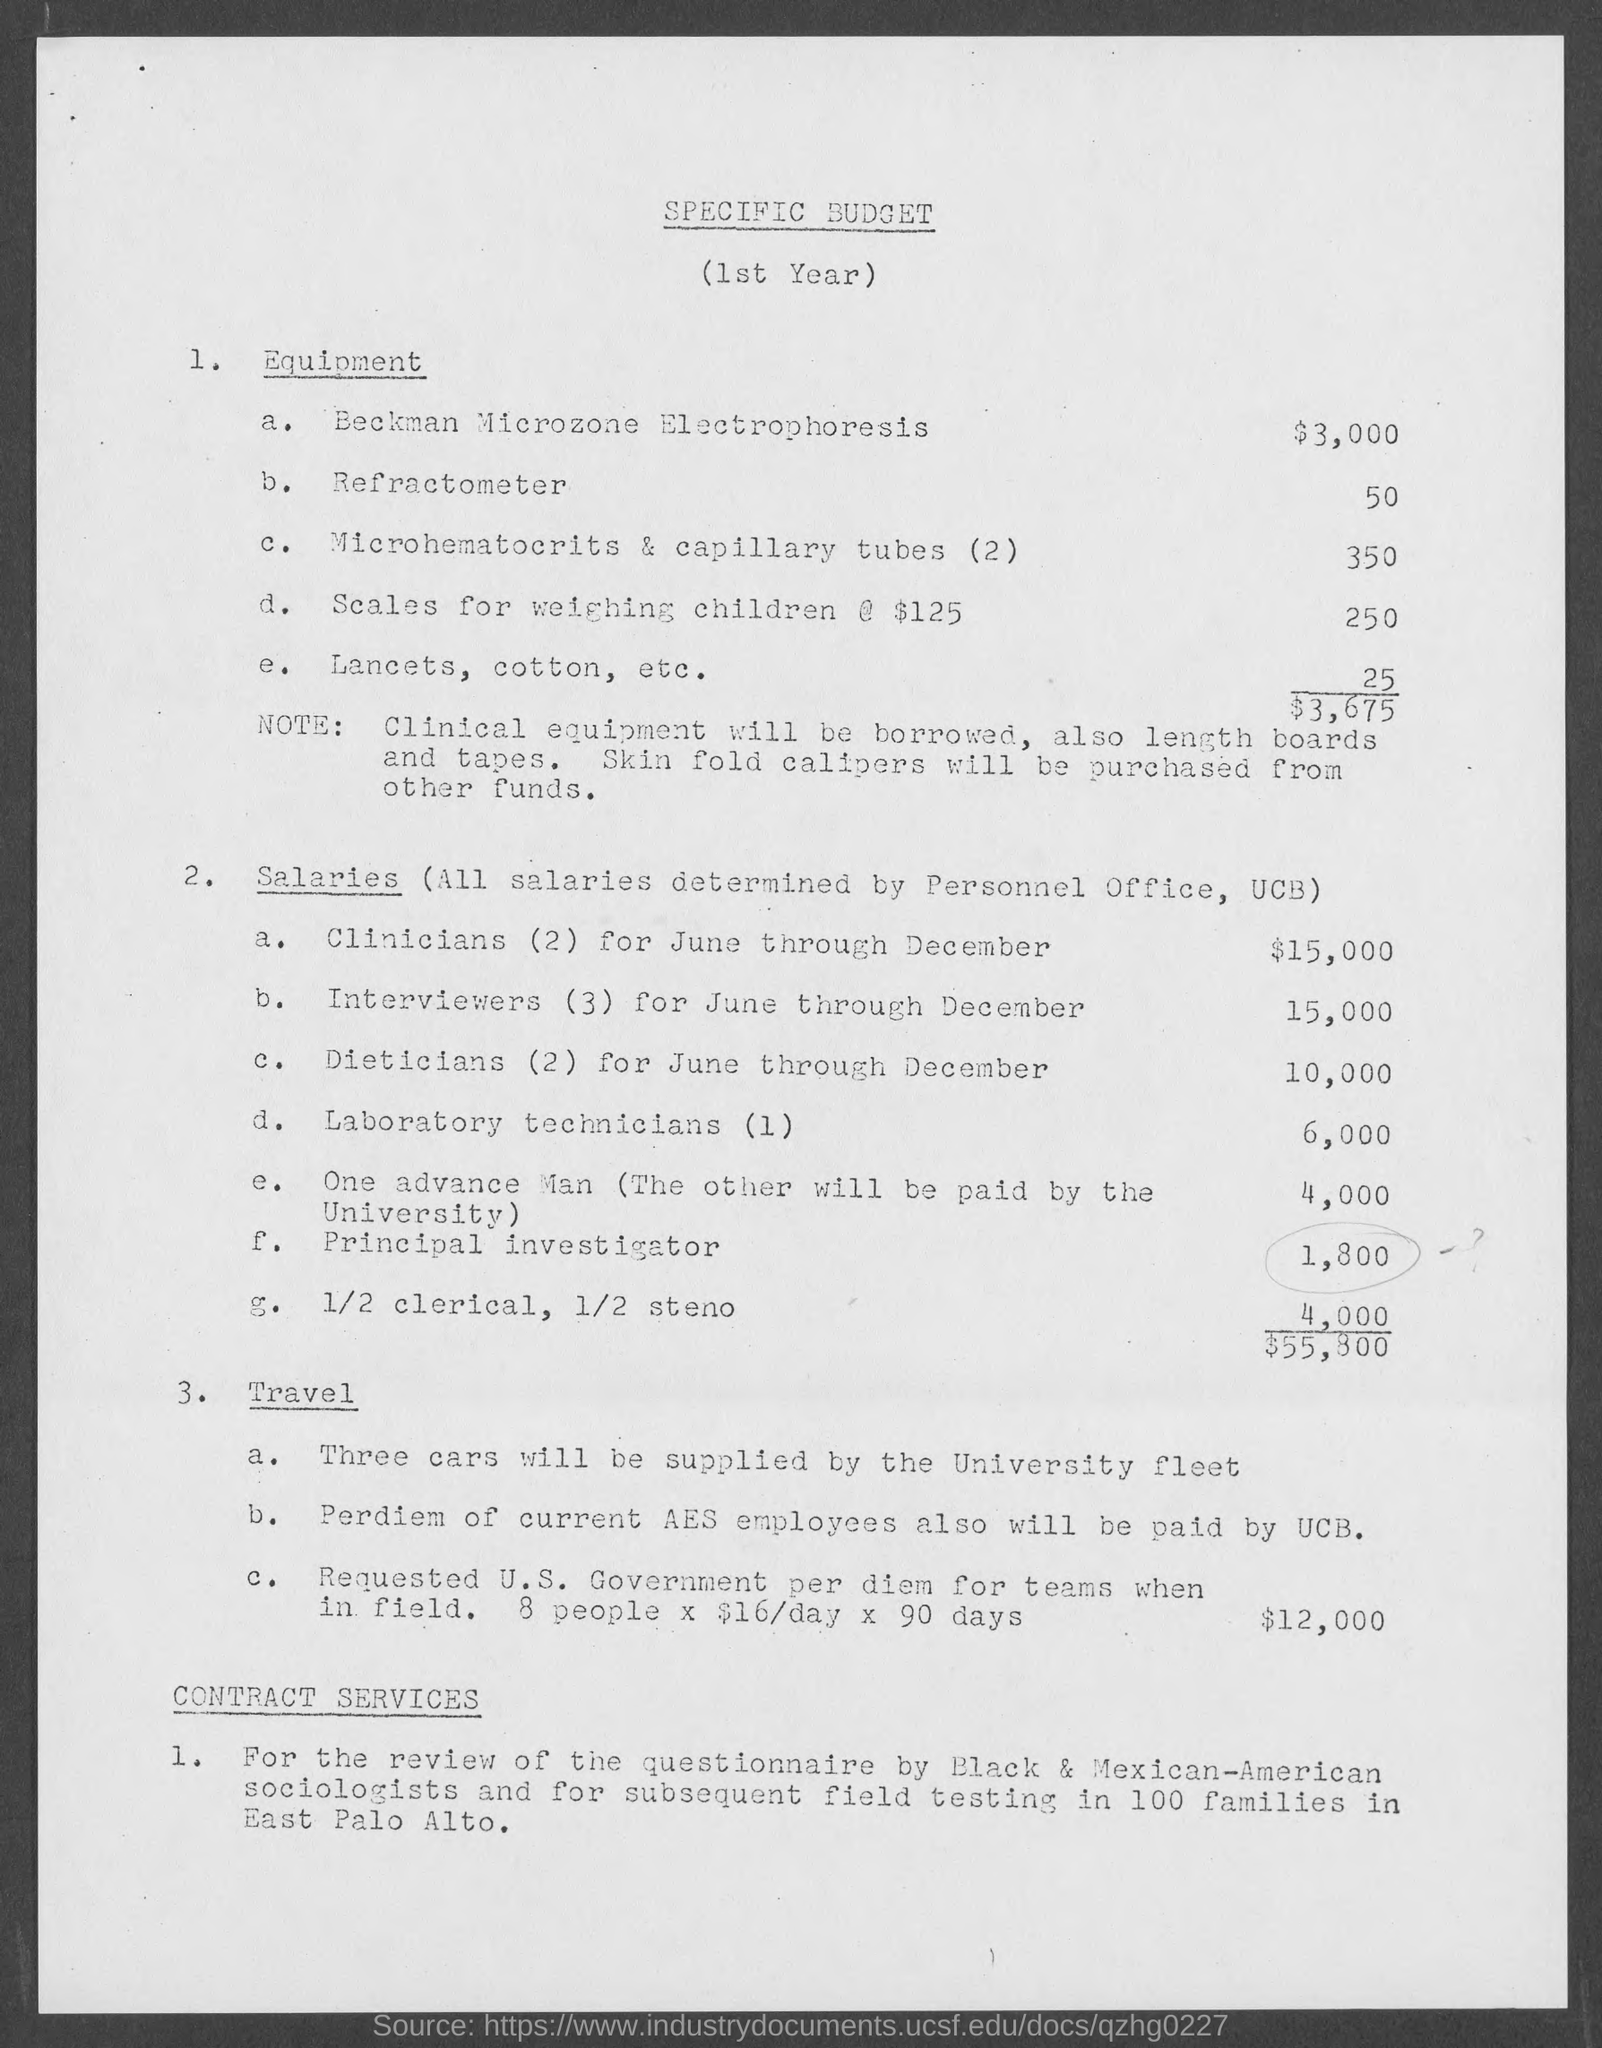What is the Cost for Beckman Microzone Electrophoresis?
 $3,000 